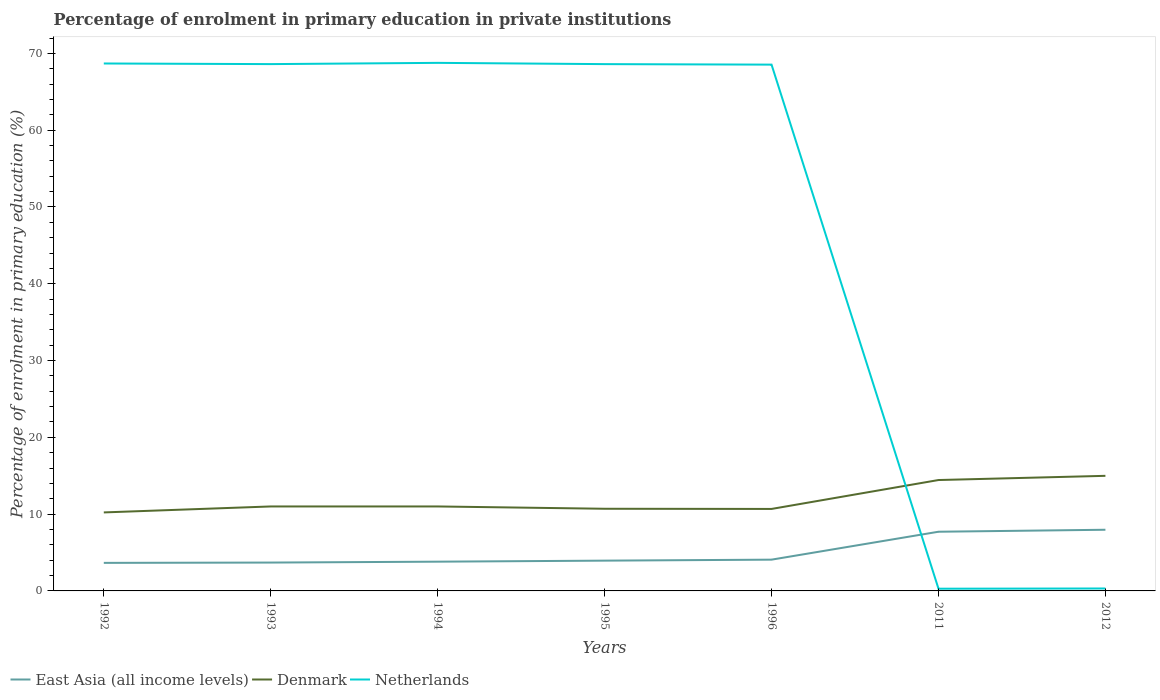How many different coloured lines are there?
Ensure brevity in your answer.  3. Does the line corresponding to East Asia (all income levels) intersect with the line corresponding to Netherlands?
Give a very brief answer. Yes. Is the number of lines equal to the number of legend labels?
Offer a terse response. Yes. Across all years, what is the maximum percentage of enrolment in primary education in Netherlands?
Your response must be concise. 0.29. In which year was the percentage of enrolment in primary education in Netherlands maximum?
Make the answer very short. 2011. What is the total percentage of enrolment in primary education in Denmark in the graph?
Ensure brevity in your answer.  -0.55. What is the difference between the highest and the second highest percentage of enrolment in primary education in East Asia (all income levels)?
Keep it short and to the point. 4.31. What is the difference between the highest and the lowest percentage of enrolment in primary education in East Asia (all income levels)?
Provide a short and direct response. 2. Is the percentage of enrolment in primary education in Netherlands strictly greater than the percentage of enrolment in primary education in East Asia (all income levels) over the years?
Offer a very short reply. No. How many lines are there?
Ensure brevity in your answer.  3. How many years are there in the graph?
Your answer should be compact. 7. Does the graph contain any zero values?
Offer a terse response. No. Where does the legend appear in the graph?
Your answer should be very brief. Bottom left. How many legend labels are there?
Give a very brief answer. 3. What is the title of the graph?
Offer a very short reply. Percentage of enrolment in primary education in private institutions. What is the label or title of the Y-axis?
Provide a succinct answer. Percentage of enrolment in primary education (%). What is the Percentage of enrolment in primary education (%) of East Asia (all income levels) in 1992?
Keep it short and to the point. 3.65. What is the Percentage of enrolment in primary education (%) of Denmark in 1992?
Your answer should be compact. 10.22. What is the Percentage of enrolment in primary education (%) of Netherlands in 1992?
Provide a short and direct response. 68.69. What is the Percentage of enrolment in primary education (%) of East Asia (all income levels) in 1993?
Make the answer very short. 3.69. What is the Percentage of enrolment in primary education (%) in Denmark in 1993?
Offer a terse response. 11. What is the Percentage of enrolment in primary education (%) in Netherlands in 1993?
Offer a very short reply. 68.61. What is the Percentage of enrolment in primary education (%) in East Asia (all income levels) in 1994?
Make the answer very short. 3.81. What is the Percentage of enrolment in primary education (%) of Denmark in 1994?
Your response must be concise. 11. What is the Percentage of enrolment in primary education (%) of Netherlands in 1994?
Your answer should be compact. 68.77. What is the Percentage of enrolment in primary education (%) of East Asia (all income levels) in 1995?
Ensure brevity in your answer.  3.94. What is the Percentage of enrolment in primary education (%) in Denmark in 1995?
Offer a terse response. 10.7. What is the Percentage of enrolment in primary education (%) of Netherlands in 1995?
Keep it short and to the point. 68.61. What is the Percentage of enrolment in primary education (%) of East Asia (all income levels) in 1996?
Offer a very short reply. 4.07. What is the Percentage of enrolment in primary education (%) in Denmark in 1996?
Keep it short and to the point. 10.68. What is the Percentage of enrolment in primary education (%) in Netherlands in 1996?
Offer a terse response. 68.54. What is the Percentage of enrolment in primary education (%) of East Asia (all income levels) in 2011?
Give a very brief answer. 7.71. What is the Percentage of enrolment in primary education (%) in Denmark in 2011?
Your response must be concise. 14.44. What is the Percentage of enrolment in primary education (%) of Netherlands in 2011?
Your answer should be very brief. 0.29. What is the Percentage of enrolment in primary education (%) of East Asia (all income levels) in 2012?
Provide a succinct answer. 7.97. What is the Percentage of enrolment in primary education (%) of Denmark in 2012?
Give a very brief answer. 14.99. What is the Percentage of enrolment in primary education (%) of Netherlands in 2012?
Provide a short and direct response. 0.32. Across all years, what is the maximum Percentage of enrolment in primary education (%) in East Asia (all income levels)?
Provide a succinct answer. 7.97. Across all years, what is the maximum Percentage of enrolment in primary education (%) of Denmark?
Ensure brevity in your answer.  14.99. Across all years, what is the maximum Percentage of enrolment in primary education (%) of Netherlands?
Your answer should be very brief. 68.77. Across all years, what is the minimum Percentage of enrolment in primary education (%) in East Asia (all income levels)?
Offer a very short reply. 3.65. Across all years, what is the minimum Percentage of enrolment in primary education (%) in Denmark?
Your answer should be compact. 10.22. Across all years, what is the minimum Percentage of enrolment in primary education (%) of Netherlands?
Your answer should be compact. 0.29. What is the total Percentage of enrolment in primary education (%) of East Asia (all income levels) in the graph?
Make the answer very short. 34.84. What is the total Percentage of enrolment in primary education (%) in Denmark in the graph?
Keep it short and to the point. 83.03. What is the total Percentage of enrolment in primary education (%) of Netherlands in the graph?
Keep it short and to the point. 343.81. What is the difference between the Percentage of enrolment in primary education (%) of East Asia (all income levels) in 1992 and that in 1993?
Make the answer very short. -0.04. What is the difference between the Percentage of enrolment in primary education (%) of Denmark in 1992 and that in 1993?
Provide a short and direct response. -0.78. What is the difference between the Percentage of enrolment in primary education (%) in Netherlands in 1992 and that in 1993?
Give a very brief answer. 0.08. What is the difference between the Percentage of enrolment in primary education (%) in East Asia (all income levels) in 1992 and that in 1994?
Provide a short and direct response. -0.16. What is the difference between the Percentage of enrolment in primary education (%) in Denmark in 1992 and that in 1994?
Ensure brevity in your answer.  -0.78. What is the difference between the Percentage of enrolment in primary education (%) of Netherlands in 1992 and that in 1994?
Offer a terse response. -0.08. What is the difference between the Percentage of enrolment in primary education (%) in East Asia (all income levels) in 1992 and that in 1995?
Offer a terse response. -0.29. What is the difference between the Percentage of enrolment in primary education (%) of Denmark in 1992 and that in 1995?
Make the answer very short. -0.48. What is the difference between the Percentage of enrolment in primary education (%) in Netherlands in 1992 and that in 1995?
Your answer should be compact. 0.08. What is the difference between the Percentage of enrolment in primary education (%) in East Asia (all income levels) in 1992 and that in 1996?
Offer a terse response. -0.42. What is the difference between the Percentage of enrolment in primary education (%) in Denmark in 1992 and that in 1996?
Provide a succinct answer. -0.45. What is the difference between the Percentage of enrolment in primary education (%) in Netherlands in 1992 and that in 1996?
Offer a terse response. 0.15. What is the difference between the Percentage of enrolment in primary education (%) in East Asia (all income levels) in 1992 and that in 2011?
Make the answer very short. -4.05. What is the difference between the Percentage of enrolment in primary education (%) of Denmark in 1992 and that in 2011?
Provide a succinct answer. -4.22. What is the difference between the Percentage of enrolment in primary education (%) of Netherlands in 1992 and that in 2011?
Offer a terse response. 68.4. What is the difference between the Percentage of enrolment in primary education (%) in East Asia (all income levels) in 1992 and that in 2012?
Your response must be concise. -4.31. What is the difference between the Percentage of enrolment in primary education (%) in Denmark in 1992 and that in 2012?
Offer a very short reply. -4.77. What is the difference between the Percentage of enrolment in primary education (%) of Netherlands in 1992 and that in 2012?
Give a very brief answer. 68.37. What is the difference between the Percentage of enrolment in primary education (%) of East Asia (all income levels) in 1993 and that in 1994?
Your response must be concise. -0.12. What is the difference between the Percentage of enrolment in primary education (%) in Netherlands in 1993 and that in 1994?
Your response must be concise. -0.16. What is the difference between the Percentage of enrolment in primary education (%) in East Asia (all income levels) in 1993 and that in 1995?
Give a very brief answer. -0.25. What is the difference between the Percentage of enrolment in primary education (%) of Netherlands in 1993 and that in 1995?
Offer a terse response. 0. What is the difference between the Percentage of enrolment in primary education (%) in East Asia (all income levels) in 1993 and that in 1996?
Make the answer very short. -0.38. What is the difference between the Percentage of enrolment in primary education (%) of Denmark in 1993 and that in 1996?
Your answer should be compact. 0.32. What is the difference between the Percentage of enrolment in primary education (%) in Netherlands in 1993 and that in 1996?
Provide a short and direct response. 0.07. What is the difference between the Percentage of enrolment in primary education (%) of East Asia (all income levels) in 1993 and that in 2011?
Offer a very short reply. -4.02. What is the difference between the Percentage of enrolment in primary education (%) of Denmark in 1993 and that in 2011?
Provide a short and direct response. -3.44. What is the difference between the Percentage of enrolment in primary education (%) in Netherlands in 1993 and that in 2011?
Ensure brevity in your answer.  68.32. What is the difference between the Percentage of enrolment in primary education (%) of East Asia (all income levels) in 1993 and that in 2012?
Give a very brief answer. -4.27. What is the difference between the Percentage of enrolment in primary education (%) in Denmark in 1993 and that in 2012?
Your answer should be very brief. -3.99. What is the difference between the Percentage of enrolment in primary education (%) in Netherlands in 1993 and that in 2012?
Provide a short and direct response. 68.29. What is the difference between the Percentage of enrolment in primary education (%) of East Asia (all income levels) in 1994 and that in 1995?
Keep it short and to the point. -0.13. What is the difference between the Percentage of enrolment in primary education (%) in Denmark in 1994 and that in 1995?
Offer a very short reply. 0.3. What is the difference between the Percentage of enrolment in primary education (%) in Netherlands in 1994 and that in 1995?
Ensure brevity in your answer.  0.16. What is the difference between the Percentage of enrolment in primary education (%) of East Asia (all income levels) in 1994 and that in 1996?
Your answer should be very brief. -0.26. What is the difference between the Percentage of enrolment in primary education (%) in Denmark in 1994 and that in 1996?
Keep it short and to the point. 0.32. What is the difference between the Percentage of enrolment in primary education (%) of Netherlands in 1994 and that in 1996?
Make the answer very short. 0.23. What is the difference between the Percentage of enrolment in primary education (%) of East Asia (all income levels) in 1994 and that in 2011?
Your answer should be very brief. -3.9. What is the difference between the Percentage of enrolment in primary education (%) in Denmark in 1994 and that in 2011?
Provide a succinct answer. -3.44. What is the difference between the Percentage of enrolment in primary education (%) of Netherlands in 1994 and that in 2011?
Provide a succinct answer. 68.48. What is the difference between the Percentage of enrolment in primary education (%) of East Asia (all income levels) in 1994 and that in 2012?
Offer a very short reply. -4.16. What is the difference between the Percentage of enrolment in primary education (%) in Denmark in 1994 and that in 2012?
Make the answer very short. -3.99. What is the difference between the Percentage of enrolment in primary education (%) in Netherlands in 1994 and that in 2012?
Ensure brevity in your answer.  68.45. What is the difference between the Percentage of enrolment in primary education (%) in East Asia (all income levels) in 1995 and that in 1996?
Ensure brevity in your answer.  -0.13. What is the difference between the Percentage of enrolment in primary education (%) in Denmark in 1995 and that in 1996?
Give a very brief answer. 0.02. What is the difference between the Percentage of enrolment in primary education (%) in Netherlands in 1995 and that in 1996?
Make the answer very short. 0.07. What is the difference between the Percentage of enrolment in primary education (%) of East Asia (all income levels) in 1995 and that in 2011?
Offer a very short reply. -3.77. What is the difference between the Percentage of enrolment in primary education (%) in Denmark in 1995 and that in 2011?
Your answer should be very brief. -3.74. What is the difference between the Percentage of enrolment in primary education (%) of Netherlands in 1995 and that in 2011?
Offer a terse response. 68.32. What is the difference between the Percentage of enrolment in primary education (%) of East Asia (all income levels) in 1995 and that in 2012?
Your response must be concise. -4.02. What is the difference between the Percentage of enrolment in primary education (%) in Denmark in 1995 and that in 2012?
Give a very brief answer. -4.29. What is the difference between the Percentage of enrolment in primary education (%) of Netherlands in 1995 and that in 2012?
Keep it short and to the point. 68.29. What is the difference between the Percentage of enrolment in primary education (%) in East Asia (all income levels) in 1996 and that in 2011?
Your answer should be compact. -3.64. What is the difference between the Percentage of enrolment in primary education (%) in Denmark in 1996 and that in 2011?
Make the answer very short. -3.76. What is the difference between the Percentage of enrolment in primary education (%) in Netherlands in 1996 and that in 2011?
Offer a terse response. 68.25. What is the difference between the Percentage of enrolment in primary education (%) of East Asia (all income levels) in 1996 and that in 2012?
Offer a very short reply. -3.89. What is the difference between the Percentage of enrolment in primary education (%) of Denmark in 1996 and that in 2012?
Offer a terse response. -4.31. What is the difference between the Percentage of enrolment in primary education (%) of Netherlands in 1996 and that in 2012?
Give a very brief answer. 68.22. What is the difference between the Percentage of enrolment in primary education (%) in East Asia (all income levels) in 2011 and that in 2012?
Your answer should be very brief. -0.26. What is the difference between the Percentage of enrolment in primary education (%) of Denmark in 2011 and that in 2012?
Your answer should be very brief. -0.55. What is the difference between the Percentage of enrolment in primary education (%) of Netherlands in 2011 and that in 2012?
Your response must be concise. -0.03. What is the difference between the Percentage of enrolment in primary education (%) of East Asia (all income levels) in 1992 and the Percentage of enrolment in primary education (%) of Denmark in 1993?
Your response must be concise. -7.35. What is the difference between the Percentage of enrolment in primary education (%) in East Asia (all income levels) in 1992 and the Percentage of enrolment in primary education (%) in Netherlands in 1993?
Your answer should be compact. -64.95. What is the difference between the Percentage of enrolment in primary education (%) in Denmark in 1992 and the Percentage of enrolment in primary education (%) in Netherlands in 1993?
Your response must be concise. -58.38. What is the difference between the Percentage of enrolment in primary education (%) of East Asia (all income levels) in 1992 and the Percentage of enrolment in primary education (%) of Denmark in 1994?
Offer a terse response. -7.35. What is the difference between the Percentage of enrolment in primary education (%) of East Asia (all income levels) in 1992 and the Percentage of enrolment in primary education (%) of Netherlands in 1994?
Make the answer very short. -65.11. What is the difference between the Percentage of enrolment in primary education (%) in Denmark in 1992 and the Percentage of enrolment in primary education (%) in Netherlands in 1994?
Your answer should be very brief. -58.55. What is the difference between the Percentage of enrolment in primary education (%) in East Asia (all income levels) in 1992 and the Percentage of enrolment in primary education (%) in Denmark in 1995?
Provide a succinct answer. -7.05. What is the difference between the Percentage of enrolment in primary education (%) of East Asia (all income levels) in 1992 and the Percentage of enrolment in primary education (%) of Netherlands in 1995?
Keep it short and to the point. -64.95. What is the difference between the Percentage of enrolment in primary education (%) of Denmark in 1992 and the Percentage of enrolment in primary education (%) of Netherlands in 1995?
Ensure brevity in your answer.  -58.38. What is the difference between the Percentage of enrolment in primary education (%) of East Asia (all income levels) in 1992 and the Percentage of enrolment in primary education (%) of Denmark in 1996?
Provide a short and direct response. -7.02. What is the difference between the Percentage of enrolment in primary education (%) of East Asia (all income levels) in 1992 and the Percentage of enrolment in primary education (%) of Netherlands in 1996?
Give a very brief answer. -64.89. What is the difference between the Percentage of enrolment in primary education (%) in Denmark in 1992 and the Percentage of enrolment in primary education (%) in Netherlands in 1996?
Offer a very short reply. -58.32. What is the difference between the Percentage of enrolment in primary education (%) in East Asia (all income levels) in 1992 and the Percentage of enrolment in primary education (%) in Denmark in 2011?
Your response must be concise. -10.79. What is the difference between the Percentage of enrolment in primary education (%) of East Asia (all income levels) in 1992 and the Percentage of enrolment in primary education (%) of Netherlands in 2011?
Keep it short and to the point. 3.36. What is the difference between the Percentage of enrolment in primary education (%) in Denmark in 1992 and the Percentage of enrolment in primary education (%) in Netherlands in 2011?
Make the answer very short. 9.93. What is the difference between the Percentage of enrolment in primary education (%) in East Asia (all income levels) in 1992 and the Percentage of enrolment in primary education (%) in Denmark in 2012?
Ensure brevity in your answer.  -11.34. What is the difference between the Percentage of enrolment in primary education (%) of East Asia (all income levels) in 1992 and the Percentage of enrolment in primary education (%) of Netherlands in 2012?
Give a very brief answer. 3.34. What is the difference between the Percentage of enrolment in primary education (%) in Denmark in 1992 and the Percentage of enrolment in primary education (%) in Netherlands in 2012?
Your response must be concise. 9.9. What is the difference between the Percentage of enrolment in primary education (%) of East Asia (all income levels) in 1993 and the Percentage of enrolment in primary education (%) of Denmark in 1994?
Provide a short and direct response. -7.31. What is the difference between the Percentage of enrolment in primary education (%) in East Asia (all income levels) in 1993 and the Percentage of enrolment in primary education (%) in Netherlands in 1994?
Keep it short and to the point. -65.08. What is the difference between the Percentage of enrolment in primary education (%) of Denmark in 1993 and the Percentage of enrolment in primary education (%) of Netherlands in 1994?
Your answer should be compact. -57.77. What is the difference between the Percentage of enrolment in primary education (%) in East Asia (all income levels) in 1993 and the Percentage of enrolment in primary education (%) in Denmark in 1995?
Your response must be concise. -7.01. What is the difference between the Percentage of enrolment in primary education (%) of East Asia (all income levels) in 1993 and the Percentage of enrolment in primary education (%) of Netherlands in 1995?
Provide a succinct answer. -64.91. What is the difference between the Percentage of enrolment in primary education (%) of Denmark in 1993 and the Percentage of enrolment in primary education (%) of Netherlands in 1995?
Your response must be concise. -57.6. What is the difference between the Percentage of enrolment in primary education (%) in East Asia (all income levels) in 1993 and the Percentage of enrolment in primary education (%) in Denmark in 1996?
Give a very brief answer. -6.98. What is the difference between the Percentage of enrolment in primary education (%) of East Asia (all income levels) in 1993 and the Percentage of enrolment in primary education (%) of Netherlands in 1996?
Ensure brevity in your answer.  -64.85. What is the difference between the Percentage of enrolment in primary education (%) of Denmark in 1993 and the Percentage of enrolment in primary education (%) of Netherlands in 1996?
Provide a succinct answer. -57.54. What is the difference between the Percentage of enrolment in primary education (%) of East Asia (all income levels) in 1993 and the Percentage of enrolment in primary education (%) of Denmark in 2011?
Your answer should be very brief. -10.75. What is the difference between the Percentage of enrolment in primary education (%) in East Asia (all income levels) in 1993 and the Percentage of enrolment in primary education (%) in Netherlands in 2011?
Keep it short and to the point. 3.4. What is the difference between the Percentage of enrolment in primary education (%) of Denmark in 1993 and the Percentage of enrolment in primary education (%) of Netherlands in 2011?
Your answer should be compact. 10.71. What is the difference between the Percentage of enrolment in primary education (%) of East Asia (all income levels) in 1993 and the Percentage of enrolment in primary education (%) of Denmark in 2012?
Your answer should be very brief. -11.3. What is the difference between the Percentage of enrolment in primary education (%) in East Asia (all income levels) in 1993 and the Percentage of enrolment in primary education (%) in Netherlands in 2012?
Your answer should be very brief. 3.38. What is the difference between the Percentage of enrolment in primary education (%) in Denmark in 1993 and the Percentage of enrolment in primary education (%) in Netherlands in 2012?
Give a very brief answer. 10.68. What is the difference between the Percentage of enrolment in primary education (%) in East Asia (all income levels) in 1994 and the Percentage of enrolment in primary education (%) in Denmark in 1995?
Your response must be concise. -6.89. What is the difference between the Percentage of enrolment in primary education (%) of East Asia (all income levels) in 1994 and the Percentage of enrolment in primary education (%) of Netherlands in 1995?
Your answer should be compact. -64.8. What is the difference between the Percentage of enrolment in primary education (%) in Denmark in 1994 and the Percentage of enrolment in primary education (%) in Netherlands in 1995?
Ensure brevity in your answer.  -57.61. What is the difference between the Percentage of enrolment in primary education (%) in East Asia (all income levels) in 1994 and the Percentage of enrolment in primary education (%) in Denmark in 1996?
Keep it short and to the point. -6.87. What is the difference between the Percentage of enrolment in primary education (%) in East Asia (all income levels) in 1994 and the Percentage of enrolment in primary education (%) in Netherlands in 1996?
Offer a very short reply. -64.73. What is the difference between the Percentage of enrolment in primary education (%) of Denmark in 1994 and the Percentage of enrolment in primary education (%) of Netherlands in 1996?
Give a very brief answer. -57.54. What is the difference between the Percentage of enrolment in primary education (%) of East Asia (all income levels) in 1994 and the Percentage of enrolment in primary education (%) of Denmark in 2011?
Provide a short and direct response. -10.63. What is the difference between the Percentage of enrolment in primary education (%) of East Asia (all income levels) in 1994 and the Percentage of enrolment in primary education (%) of Netherlands in 2011?
Ensure brevity in your answer.  3.52. What is the difference between the Percentage of enrolment in primary education (%) of Denmark in 1994 and the Percentage of enrolment in primary education (%) of Netherlands in 2011?
Ensure brevity in your answer.  10.71. What is the difference between the Percentage of enrolment in primary education (%) of East Asia (all income levels) in 1994 and the Percentage of enrolment in primary education (%) of Denmark in 2012?
Offer a very short reply. -11.18. What is the difference between the Percentage of enrolment in primary education (%) of East Asia (all income levels) in 1994 and the Percentage of enrolment in primary education (%) of Netherlands in 2012?
Ensure brevity in your answer.  3.49. What is the difference between the Percentage of enrolment in primary education (%) in Denmark in 1994 and the Percentage of enrolment in primary education (%) in Netherlands in 2012?
Give a very brief answer. 10.68. What is the difference between the Percentage of enrolment in primary education (%) of East Asia (all income levels) in 1995 and the Percentage of enrolment in primary education (%) of Denmark in 1996?
Keep it short and to the point. -6.73. What is the difference between the Percentage of enrolment in primary education (%) in East Asia (all income levels) in 1995 and the Percentage of enrolment in primary education (%) in Netherlands in 1996?
Your answer should be very brief. -64.6. What is the difference between the Percentage of enrolment in primary education (%) of Denmark in 1995 and the Percentage of enrolment in primary education (%) of Netherlands in 1996?
Give a very brief answer. -57.84. What is the difference between the Percentage of enrolment in primary education (%) in East Asia (all income levels) in 1995 and the Percentage of enrolment in primary education (%) in Denmark in 2011?
Provide a succinct answer. -10.5. What is the difference between the Percentage of enrolment in primary education (%) in East Asia (all income levels) in 1995 and the Percentage of enrolment in primary education (%) in Netherlands in 2011?
Give a very brief answer. 3.65. What is the difference between the Percentage of enrolment in primary education (%) of Denmark in 1995 and the Percentage of enrolment in primary education (%) of Netherlands in 2011?
Offer a very short reply. 10.41. What is the difference between the Percentage of enrolment in primary education (%) of East Asia (all income levels) in 1995 and the Percentage of enrolment in primary education (%) of Denmark in 2012?
Ensure brevity in your answer.  -11.05. What is the difference between the Percentage of enrolment in primary education (%) in East Asia (all income levels) in 1995 and the Percentage of enrolment in primary education (%) in Netherlands in 2012?
Keep it short and to the point. 3.63. What is the difference between the Percentage of enrolment in primary education (%) of Denmark in 1995 and the Percentage of enrolment in primary education (%) of Netherlands in 2012?
Your answer should be very brief. 10.38. What is the difference between the Percentage of enrolment in primary education (%) in East Asia (all income levels) in 1996 and the Percentage of enrolment in primary education (%) in Denmark in 2011?
Provide a short and direct response. -10.37. What is the difference between the Percentage of enrolment in primary education (%) in East Asia (all income levels) in 1996 and the Percentage of enrolment in primary education (%) in Netherlands in 2011?
Your answer should be very brief. 3.78. What is the difference between the Percentage of enrolment in primary education (%) of Denmark in 1996 and the Percentage of enrolment in primary education (%) of Netherlands in 2011?
Your response must be concise. 10.39. What is the difference between the Percentage of enrolment in primary education (%) in East Asia (all income levels) in 1996 and the Percentage of enrolment in primary education (%) in Denmark in 2012?
Your answer should be compact. -10.92. What is the difference between the Percentage of enrolment in primary education (%) in East Asia (all income levels) in 1996 and the Percentage of enrolment in primary education (%) in Netherlands in 2012?
Offer a very short reply. 3.76. What is the difference between the Percentage of enrolment in primary education (%) in Denmark in 1996 and the Percentage of enrolment in primary education (%) in Netherlands in 2012?
Keep it short and to the point. 10.36. What is the difference between the Percentage of enrolment in primary education (%) in East Asia (all income levels) in 2011 and the Percentage of enrolment in primary education (%) in Denmark in 2012?
Offer a terse response. -7.28. What is the difference between the Percentage of enrolment in primary education (%) in East Asia (all income levels) in 2011 and the Percentage of enrolment in primary education (%) in Netherlands in 2012?
Provide a short and direct response. 7.39. What is the difference between the Percentage of enrolment in primary education (%) in Denmark in 2011 and the Percentage of enrolment in primary education (%) in Netherlands in 2012?
Provide a short and direct response. 14.12. What is the average Percentage of enrolment in primary education (%) in East Asia (all income levels) per year?
Your answer should be very brief. 4.98. What is the average Percentage of enrolment in primary education (%) of Denmark per year?
Your answer should be compact. 11.86. What is the average Percentage of enrolment in primary education (%) of Netherlands per year?
Make the answer very short. 49.12. In the year 1992, what is the difference between the Percentage of enrolment in primary education (%) of East Asia (all income levels) and Percentage of enrolment in primary education (%) of Denmark?
Your answer should be compact. -6.57. In the year 1992, what is the difference between the Percentage of enrolment in primary education (%) in East Asia (all income levels) and Percentage of enrolment in primary education (%) in Netherlands?
Your answer should be compact. -65.03. In the year 1992, what is the difference between the Percentage of enrolment in primary education (%) of Denmark and Percentage of enrolment in primary education (%) of Netherlands?
Provide a succinct answer. -58.46. In the year 1993, what is the difference between the Percentage of enrolment in primary education (%) in East Asia (all income levels) and Percentage of enrolment in primary education (%) in Denmark?
Your answer should be very brief. -7.31. In the year 1993, what is the difference between the Percentage of enrolment in primary education (%) of East Asia (all income levels) and Percentage of enrolment in primary education (%) of Netherlands?
Your answer should be very brief. -64.92. In the year 1993, what is the difference between the Percentage of enrolment in primary education (%) in Denmark and Percentage of enrolment in primary education (%) in Netherlands?
Ensure brevity in your answer.  -57.61. In the year 1994, what is the difference between the Percentage of enrolment in primary education (%) in East Asia (all income levels) and Percentage of enrolment in primary education (%) in Denmark?
Your answer should be very brief. -7.19. In the year 1994, what is the difference between the Percentage of enrolment in primary education (%) in East Asia (all income levels) and Percentage of enrolment in primary education (%) in Netherlands?
Ensure brevity in your answer.  -64.96. In the year 1994, what is the difference between the Percentage of enrolment in primary education (%) of Denmark and Percentage of enrolment in primary education (%) of Netherlands?
Provide a short and direct response. -57.77. In the year 1995, what is the difference between the Percentage of enrolment in primary education (%) in East Asia (all income levels) and Percentage of enrolment in primary education (%) in Denmark?
Your answer should be very brief. -6.76. In the year 1995, what is the difference between the Percentage of enrolment in primary education (%) in East Asia (all income levels) and Percentage of enrolment in primary education (%) in Netherlands?
Your response must be concise. -64.66. In the year 1995, what is the difference between the Percentage of enrolment in primary education (%) in Denmark and Percentage of enrolment in primary education (%) in Netherlands?
Ensure brevity in your answer.  -57.9. In the year 1996, what is the difference between the Percentage of enrolment in primary education (%) of East Asia (all income levels) and Percentage of enrolment in primary education (%) of Denmark?
Keep it short and to the point. -6.6. In the year 1996, what is the difference between the Percentage of enrolment in primary education (%) in East Asia (all income levels) and Percentage of enrolment in primary education (%) in Netherlands?
Make the answer very short. -64.47. In the year 1996, what is the difference between the Percentage of enrolment in primary education (%) in Denmark and Percentage of enrolment in primary education (%) in Netherlands?
Provide a succinct answer. -57.86. In the year 2011, what is the difference between the Percentage of enrolment in primary education (%) of East Asia (all income levels) and Percentage of enrolment in primary education (%) of Denmark?
Make the answer very short. -6.73. In the year 2011, what is the difference between the Percentage of enrolment in primary education (%) in East Asia (all income levels) and Percentage of enrolment in primary education (%) in Netherlands?
Give a very brief answer. 7.42. In the year 2011, what is the difference between the Percentage of enrolment in primary education (%) in Denmark and Percentage of enrolment in primary education (%) in Netherlands?
Your answer should be compact. 14.15. In the year 2012, what is the difference between the Percentage of enrolment in primary education (%) of East Asia (all income levels) and Percentage of enrolment in primary education (%) of Denmark?
Provide a succinct answer. -7.02. In the year 2012, what is the difference between the Percentage of enrolment in primary education (%) of East Asia (all income levels) and Percentage of enrolment in primary education (%) of Netherlands?
Keep it short and to the point. 7.65. In the year 2012, what is the difference between the Percentage of enrolment in primary education (%) of Denmark and Percentage of enrolment in primary education (%) of Netherlands?
Your response must be concise. 14.67. What is the ratio of the Percentage of enrolment in primary education (%) of East Asia (all income levels) in 1992 to that in 1993?
Provide a succinct answer. 0.99. What is the ratio of the Percentage of enrolment in primary education (%) in Denmark in 1992 to that in 1993?
Provide a short and direct response. 0.93. What is the ratio of the Percentage of enrolment in primary education (%) of Netherlands in 1992 to that in 1993?
Keep it short and to the point. 1. What is the ratio of the Percentage of enrolment in primary education (%) in East Asia (all income levels) in 1992 to that in 1994?
Provide a succinct answer. 0.96. What is the ratio of the Percentage of enrolment in primary education (%) of Denmark in 1992 to that in 1994?
Offer a very short reply. 0.93. What is the ratio of the Percentage of enrolment in primary education (%) in East Asia (all income levels) in 1992 to that in 1995?
Offer a very short reply. 0.93. What is the ratio of the Percentage of enrolment in primary education (%) of Denmark in 1992 to that in 1995?
Ensure brevity in your answer.  0.96. What is the ratio of the Percentage of enrolment in primary education (%) in Netherlands in 1992 to that in 1995?
Give a very brief answer. 1. What is the ratio of the Percentage of enrolment in primary education (%) of East Asia (all income levels) in 1992 to that in 1996?
Provide a short and direct response. 0.9. What is the ratio of the Percentage of enrolment in primary education (%) of Denmark in 1992 to that in 1996?
Your answer should be very brief. 0.96. What is the ratio of the Percentage of enrolment in primary education (%) of East Asia (all income levels) in 1992 to that in 2011?
Your answer should be compact. 0.47. What is the ratio of the Percentage of enrolment in primary education (%) of Denmark in 1992 to that in 2011?
Provide a short and direct response. 0.71. What is the ratio of the Percentage of enrolment in primary education (%) of Netherlands in 1992 to that in 2011?
Your answer should be compact. 237.35. What is the ratio of the Percentage of enrolment in primary education (%) in East Asia (all income levels) in 1992 to that in 2012?
Give a very brief answer. 0.46. What is the ratio of the Percentage of enrolment in primary education (%) in Denmark in 1992 to that in 2012?
Provide a succinct answer. 0.68. What is the ratio of the Percentage of enrolment in primary education (%) of Netherlands in 1992 to that in 2012?
Make the answer very short. 216.56. What is the ratio of the Percentage of enrolment in primary education (%) in East Asia (all income levels) in 1993 to that in 1994?
Provide a short and direct response. 0.97. What is the ratio of the Percentage of enrolment in primary education (%) in Denmark in 1993 to that in 1994?
Your answer should be very brief. 1. What is the ratio of the Percentage of enrolment in primary education (%) of East Asia (all income levels) in 1993 to that in 1995?
Your answer should be compact. 0.94. What is the ratio of the Percentage of enrolment in primary education (%) of Denmark in 1993 to that in 1995?
Offer a very short reply. 1.03. What is the ratio of the Percentage of enrolment in primary education (%) of Netherlands in 1993 to that in 1995?
Ensure brevity in your answer.  1. What is the ratio of the Percentage of enrolment in primary education (%) in East Asia (all income levels) in 1993 to that in 1996?
Ensure brevity in your answer.  0.91. What is the ratio of the Percentage of enrolment in primary education (%) of Denmark in 1993 to that in 1996?
Offer a very short reply. 1.03. What is the ratio of the Percentage of enrolment in primary education (%) of Netherlands in 1993 to that in 1996?
Keep it short and to the point. 1. What is the ratio of the Percentage of enrolment in primary education (%) in East Asia (all income levels) in 1993 to that in 2011?
Give a very brief answer. 0.48. What is the ratio of the Percentage of enrolment in primary education (%) of Denmark in 1993 to that in 2011?
Give a very brief answer. 0.76. What is the ratio of the Percentage of enrolment in primary education (%) in Netherlands in 1993 to that in 2011?
Ensure brevity in your answer.  237.08. What is the ratio of the Percentage of enrolment in primary education (%) in East Asia (all income levels) in 1993 to that in 2012?
Your answer should be compact. 0.46. What is the ratio of the Percentage of enrolment in primary education (%) of Denmark in 1993 to that in 2012?
Offer a terse response. 0.73. What is the ratio of the Percentage of enrolment in primary education (%) in Netherlands in 1993 to that in 2012?
Your answer should be compact. 216.3. What is the ratio of the Percentage of enrolment in primary education (%) of East Asia (all income levels) in 1994 to that in 1995?
Offer a terse response. 0.97. What is the ratio of the Percentage of enrolment in primary education (%) in Denmark in 1994 to that in 1995?
Offer a terse response. 1.03. What is the ratio of the Percentage of enrolment in primary education (%) in Netherlands in 1994 to that in 1995?
Your response must be concise. 1. What is the ratio of the Percentage of enrolment in primary education (%) of East Asia (all income levels) in 1994 to that in 1996?
Offer a very short reply. 0.94. What is the ratio of the Percentage of enrolment in primary education (%) in Denmark in 1994 to that in 1996?
Give a very brief answer. 1.03. What is the ratio of the Percentage of enrolment in primary education (%) in East Asia (all income levels) in 1994 to that in 2011?
Your response must be concise. 0.49. What is the ratio of the Percentage of enrolment in primary education (%) in Denmark in 1994 to that in 2011?
Offer a terse response. 0.76. What is the ratio of the Percentage of enrolment in primary education (%) of Netherlands in 1994 to that in 2011?
Make the answer very short. 237.63. What is the ratio of the Percentage of enrolment in primary education (%) in East Asia (all income levels) in 1994 to that in 2012?
Your answer should be very brief. 0.48. What is the ratio of the Percentage of enrolment in primary education (%) of Denmark in 1994 to that in 2012?
Your answer should be very brief. 0.73. What is the ratio of the Percentage of enrolment in primary education (%) of Netherlands in 1994 to that in 2012?
Keep it short and to the point. 216.81. What is the ratio of the Percentage of enrolment in primary education (%) of East Asia (all income levels) in 1995 to that in 1996?
Keep it short and to the point. 0.97. What is the ratio of the Percentage of enrolment in primary education (%) of Denmark in 1995 to that in 1996?
Provide a succinct answer. 1. What is the ratio of the Percentage of enrolment in primary education (%) of Netherlands in 1995 to that in 1996?
Give a very brief answer. 1. What is the ratio of the Percentage of enrolment in primary education (%) in East Asia (all income levels) in 1995 to that in 2011?
Provide a short and direct response. 0.51. What is the ratio of the Percentage of enrolment in primary education (%) in Denmark in 1995 to that in 2011?
Your response must be concise. 0.74. What is the ratio of the Percentage of enrolment in primary education (%) of Netherlands in 1995 to that in 2011?
Keep it short and to the point. 237.07. What is the ratio of the Percentage of enrolment in primary education (%) of East Asia (all income levels) in 1995 to that in 2012?
Make the answer very short. 0.49. What is the ratio of the Percentage of enrolment in primary education (%) in Denmark in 1995 to that in 2012?
Offer a terse response. 0.71. What is the ratio of the Percentage of enrolment in primary education (%) of Netherlands in 1995 to that in 2012?
Keep it short and to the point. 216.3. What is the ratio of the Percentage of enrolment in primary education (%) of East Asia (all income levels) in 1996 to that in 2011?
Ensure brevity in your answer.  0.53. What is the ratio of the Percentage of enrolment in primary education (%) of Denmark in 1996 to that in 2011?
Your answer should be very brief. 0.74. What is the ratio of the Percentage of enrolment in primary education (%) of Netherlands in 1996 to that in 2011?
Ensure brevity in your answer.  236.84. What is the ratio of the Percentage of enrolment in primary education (%) in East Asia (all income levels) in 1996 to that in 2012?
Ensure brevity in your answer.  0.51. What is the ratio of the Percentage of enrolment in primary education (%) of Denmark in 1996 to that in 2012?
Offer a very short reply. 0.71. What is the ratio of the Percentage of enrolment in primary education (%) of Netherlands in 1996 to that in 2012?
Offer a terse response. 216.09. What is the ratio of the Percentage of enrolment in primary education (%) of East Asia (all income levels) in 2011 to that in 2012?
Your answer should be very brief. 0.97. What is the ratio of the Percentage of enrolment in primary education (%) of Denmark in 2011 to that in 2012?
Make the answer very short. 0.96. What is the ratio of the Percentage of enrolment in primary education (%) in Netherlands in 2011 to that in 2012?
Keep it short and to the point. 0.91. What is the difference between the highest and the second highest Percentage of enrolment in primary education (%) in East Asia (all income levels)?
Offer a very short reply. 0.26. What is the difference between the highest and the second highest Percentage of enrolment in primary education (%) in Denmark?
Your response must be concise. 0.55. What is the difference between the highest and the second highest Percentage of enrolment in primary education (%) in Netherlands?
Your response must be concise. 0.08. What is the difference between the highest and the lowest Percentage of enrolment in primary education (%) in East Asia (all income levels)?
Offer a terse response. 4.31. What is the difference between the highest and the lowest Percentage of enrolment in primary education (%) in Denmark?
Your answer should be very brief. 4.77. What is the difference between the highest and the lowest Percentage of enrolment in primary education (%) of Netherlands?
Offer a terse response. 68.48. 